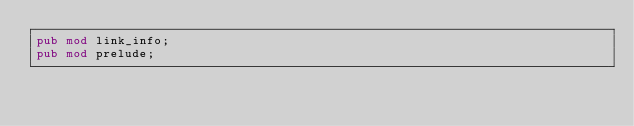Convert code to text. <code><loc_0><loc_0><loc_500><loc_500><_Rust_>pub mod link_info;
pub mod prelude;</code> 